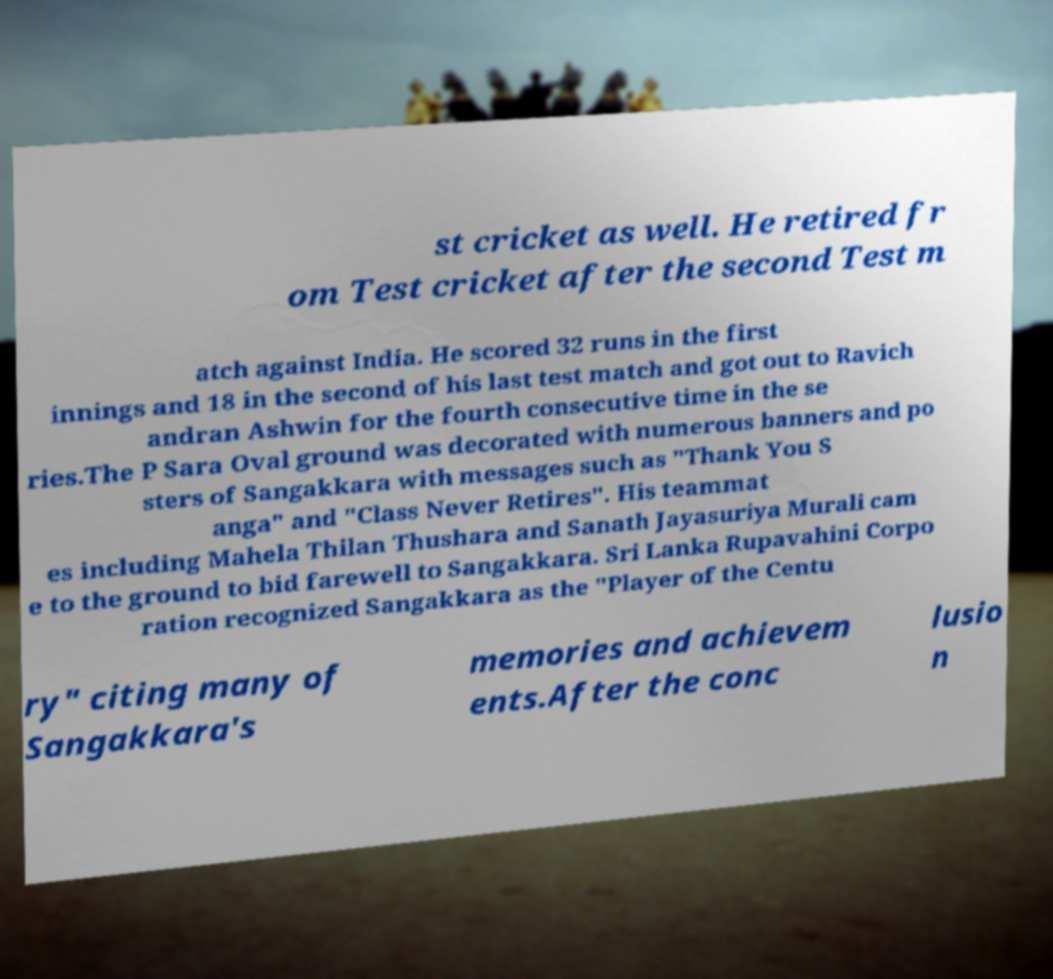Can you accurately transcribe the text from the provided image for me? st cricket as well. He retired fr om Test cricket after the second Test m atch against India. He scored 32 runs in the first innings and 18 in the second of his last test match and got out to Ravich andran Ashwin for the fourth consecutive time in the se ries.The P Sara Oval ground was decorated with numerous banners and po sters of Sangakkara with messages such as "Thank You S anga" and "Class Never Retires". His teammat es including Mahela Thilan Thushara and Sanath Jayasuriya Murali cam e to the ground to bid farewell to Sangakkara. Sri Lanka Rupavahini Corpo ration recognized Sangakkara as the "Player of the Centu ry" citing many of Sangakkara's memories and achievem ents.After the conc lusio n 